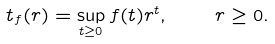Convert formula to latex. <formula><loc_0><loc_0><loc_500><loc_500>\ t _ { f } ( r ) = \sup _ { t \geq 0 } f ( t ) r ^ { t } , \quad r \geq 0 .</formula> 